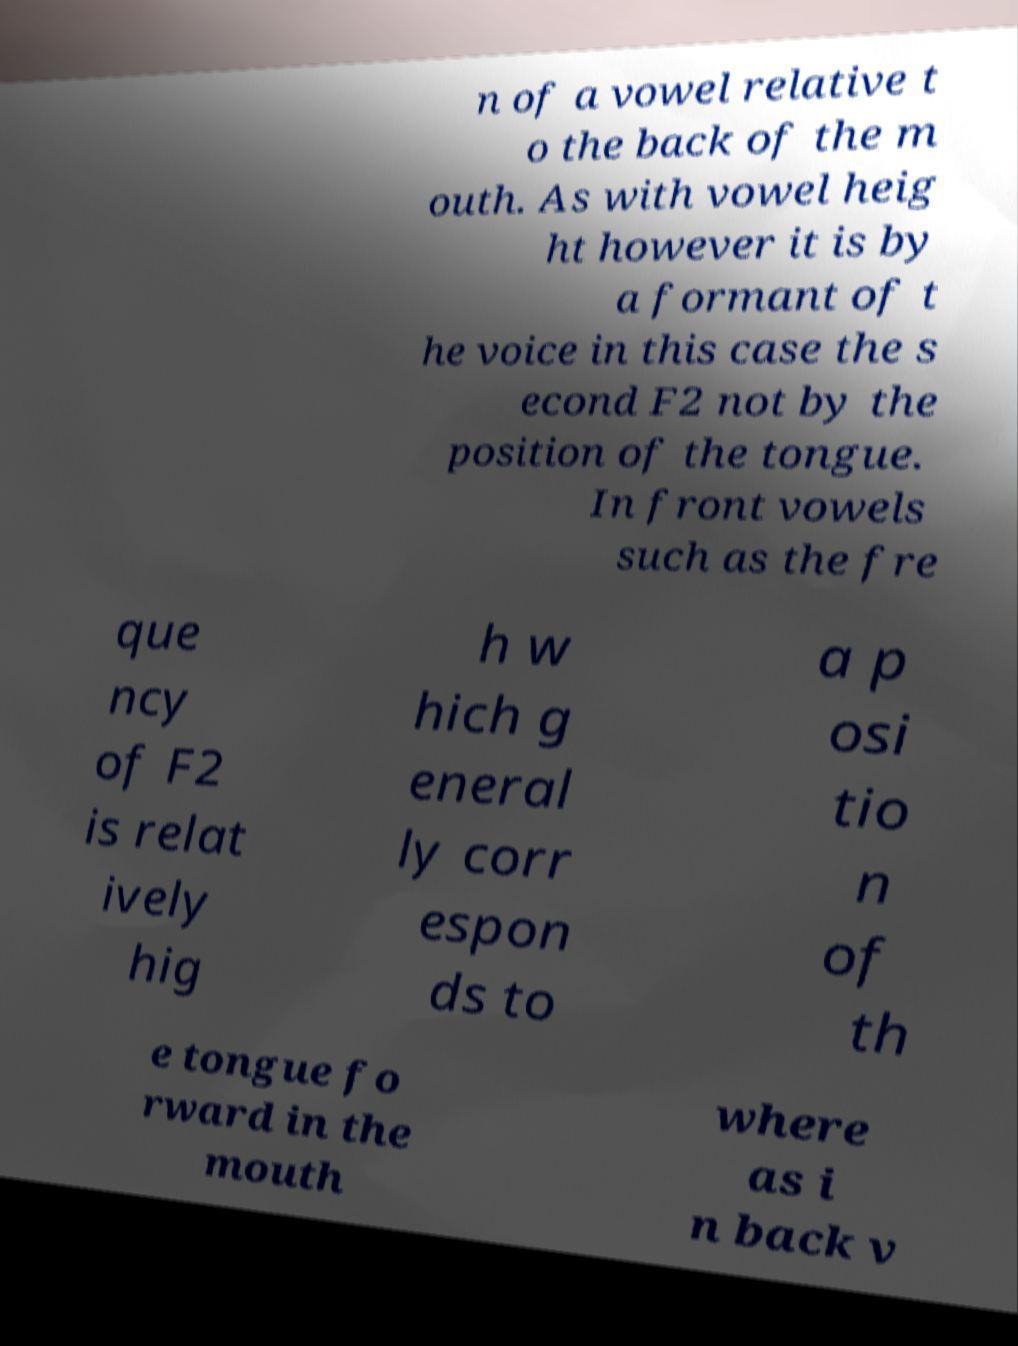There's text embedded in this image that I need extracted. Can you transcribe it verbatim? n of a vowel relative t o the back of the m outh. As with vowel heig ht however it is by a formant of t he voice in this case the s econd F2 not by the position of the tongue. In front vowels such as the fre que ncy of F2 is relat ively hig h w hich g eneral ly corr espon ds to a p osi tio n of th e tongue fo rward in the mouth where as i n back v 